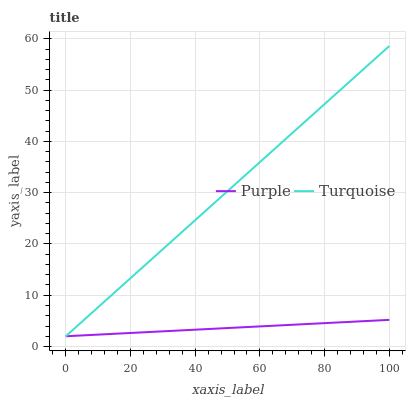Does Purple have the minimum area under the curve?
Answer yes or no. Yes. Does Turquoise have the maximum area under the curve?
Answer yes or no. Yes. Does Turquoise have the minimum area under the curve?
Answer yes or no. No. Is Purple the smoothest?
Answer yes or no. Yes. Is Turquoise the roughest?
Answer yes or no. Yes. Is Turquoise the smoothest?
Answer yes or no. No. Does Turquoise have the highest value?
Answer yes or no. Yes. Does Turquoise intersect Purple?
Answer yes or no. Yes. Is Turquoise less than Purple?
Answer yes or no. No. Is Turquoise greater than Purple?
Answer yes or no. No. 